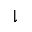<formula> <loc_0><loc_0><loc_500><loc_500>\downharpoonright</formula> 